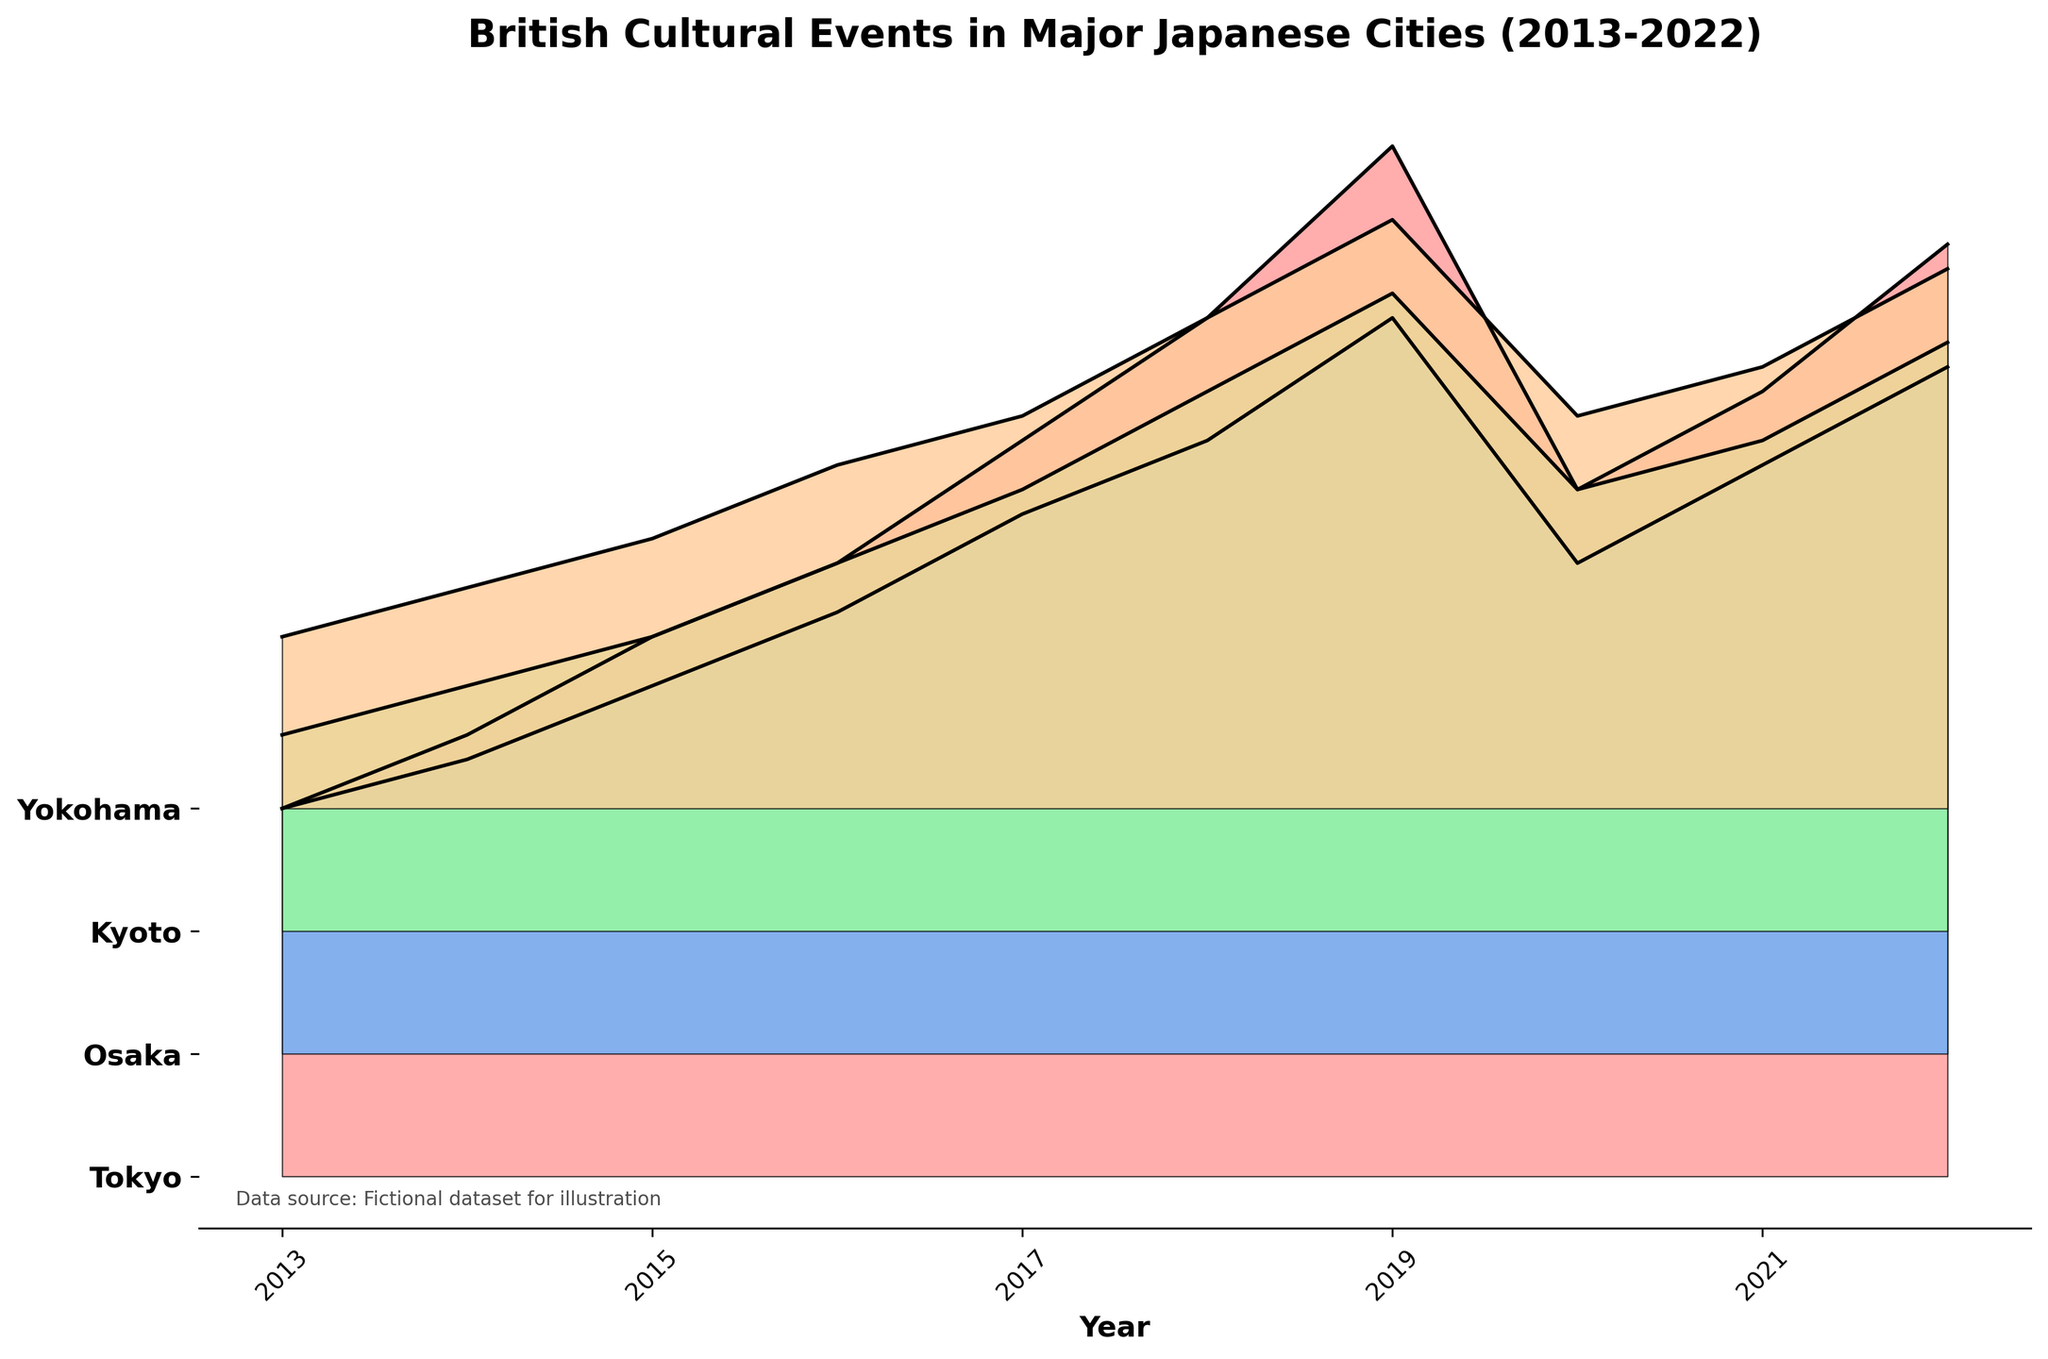How many cities are represented in the plot? The plot shows different ridgelines for each city. By counting the number of labels on the y-axis, we can determine the number of cities.
Answer: 4 Which city had the most British cultural events in 2019? By looking at the year 2019 on the x-axis and comparing the heights of the ridges for each city, we see that Tokyo's ridge reaches the highest value.
Answer: Tokyo Describe the trend of British cultural events in Osaka from 2013 to 2022. We follow the ridge labeled "Osaka" from 2013 to 2022. The ridge generally rises from 2013 to 2019, dips in 2020, and then rises again by 2022.
Answer: Rising till 2019, dip in 2020, then rising till 2022 What was the total number of British cultural events in Tokyo over the past decade? Summing up Tokyo's event counts from 2013 to 2022: 15 + 18 + 22 + 25 + 30 + 35 + 42 + 28 + 32 + 38. Total = 285.
Answer: 285 Which city had the least number of British cultural events in 2020? By examining the 2020 values for each city's ridge, we observe that Yokohama's ridge has the lowest height.
Answer: Yokohama Compare the number of cultural events in Kyoto and Yokohama in 2018. Which city had more? We examine the ridges for both Kyoto and Yokohama in 2018 on the x-axis and observe that Kyoto's ridge is higher than Yokohama's.
Answer: Kyoto Is there a steady increase in the number of British cultural events in any city? By following the ridges from 2013 to 2022, we see that no city shows a perfectly steady increase. For example, Tokyo drops in 2020, and Osaka also dips in 2020.
Answer: No Identify the city with the largest drop in events between any two consecutive years. Which years does this drop occur? Looking at the ridges, Tokyo shows a significant drop from 2019 to 2020, from 42 events to 28 events.
Answer: Tokyo, 2019-2020 